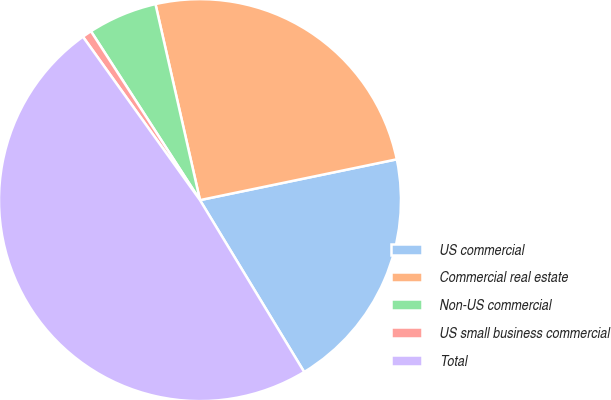Convert chart. <chart><loc_0><loc_0><loc_500><loc_500><pie_chart><fcel>US commercial<fcel>Commercial real estate<fcel>Non-US commercial<fcel>US small business commercial<fcel>Total<nl><fcel>19.58%<fcel>25.3%<fcel>5.57%<fcel>0.77%<fcel>48.78%<nl></chart> 